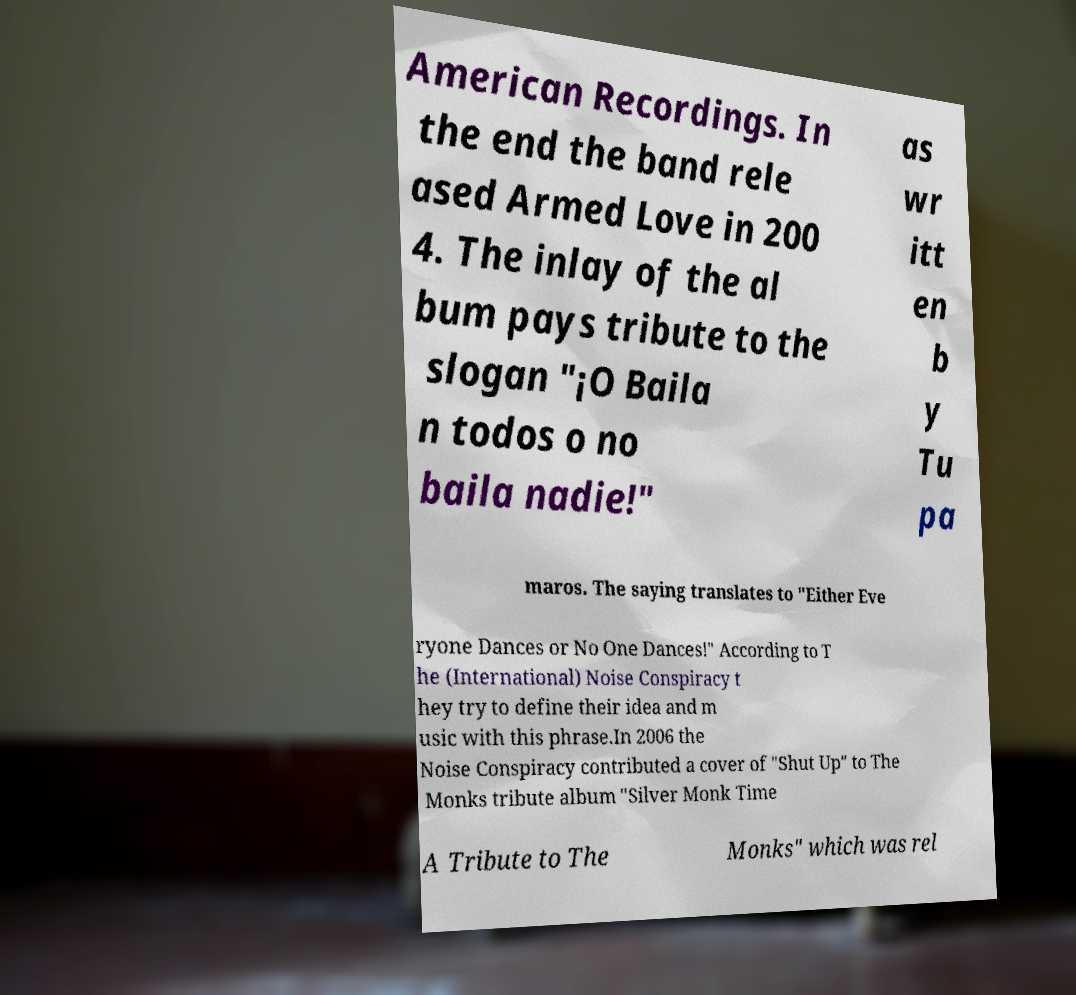Could you assist in decoding the text presented in this image and type it out clearly? American Recordings. In the end the band rele ased Armed Love in 200 4. The inlay of the al bum pays tribute to the slogan "¡O Baila n todos o no baila nadie!" as wr itt en b y Tu pa maros. The saying translates to "Either Eve ryone Dances or No One Dances!" According to T he (International) Noise Conspiracy t hey try to define their idea and m usic with this phrase.In 2006 the Noise Conspiracy contributed a cover of "Shut Up" to The Monks tribute album "Silver Monk Time A Tribute to The Monks" which was rel 